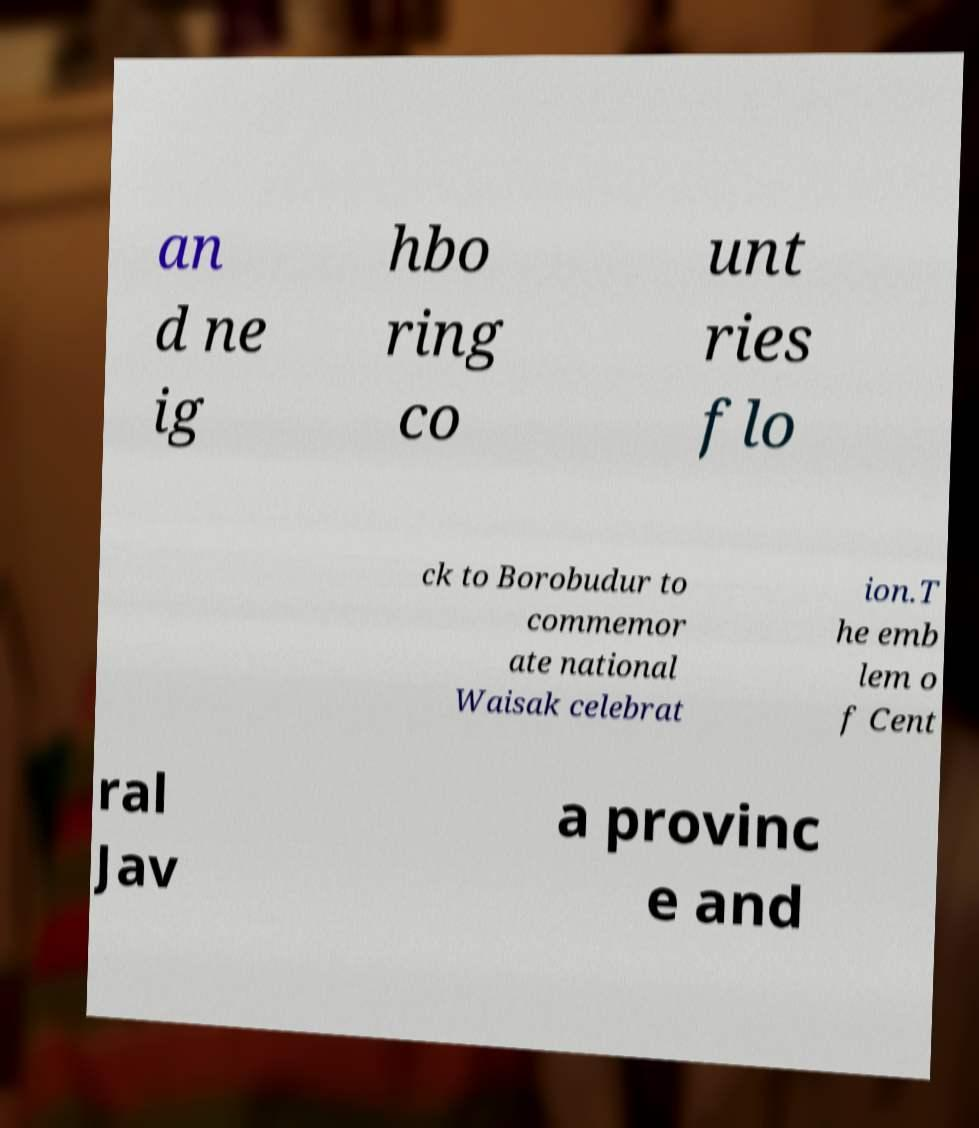Can you read and provide the text displayed in the image?This photo seems to have some interesting text. Can you extract and type it out for me? an d ne ig hbo ring co unt ries flo ck to Borobudur to commemor ate national Waisak celebrat ion.T he emb lem o f Cent ral Jav a provinc e and 